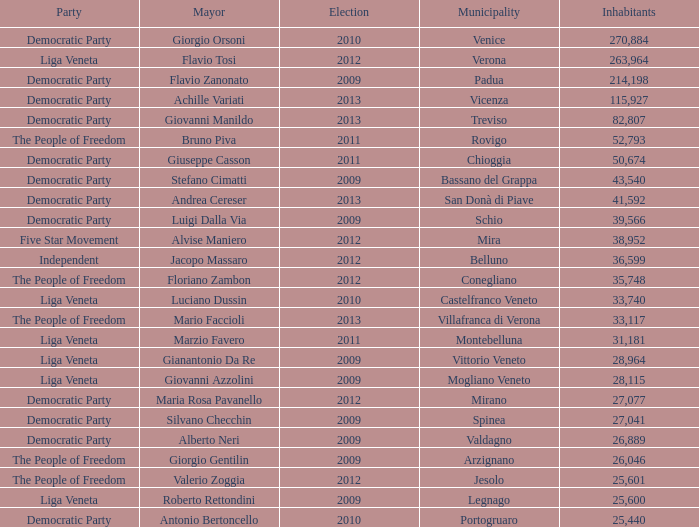In the election earlier than 2012 how many Inhabitants had a Party of five star movement? None. 